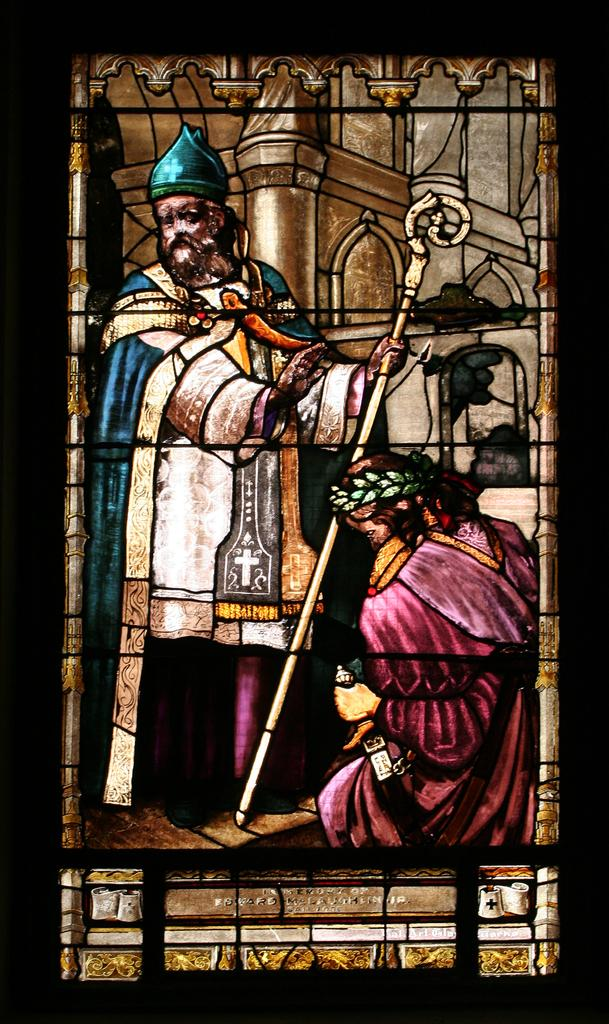How many people are present in the image? There are two persons in the image. What can be seen besides the people in the image? There is an art piece in the image. Is there any architectural feature visible in the image? Yes, there is a glass window in the image. What type of pear is being served in the lunchroom in the image? There is no lunchroom or pear present in the image. 